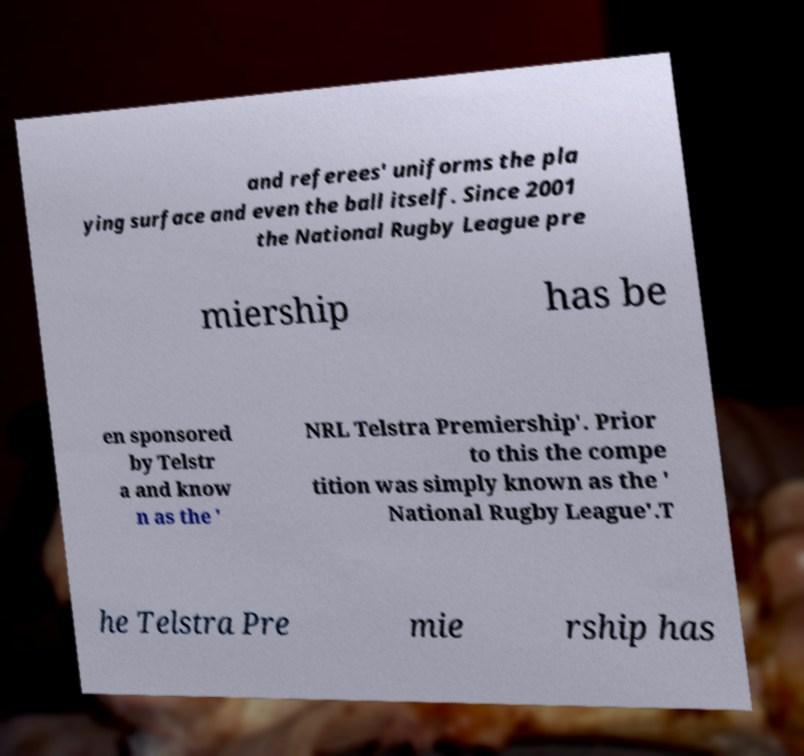What messages or text are displayed in this image? I need them in a readable, typed format. and referees' uniforms the pla ying surface and even the ball itself. Since 2001 the National Rugby League pre miership has be en sponsored by Telstr a and know n as the ' NRL Telstra Premiership'. Prior to this the compe tition was simply known as the ' National Rugby League'.T he Telstra Pre mie rship has 